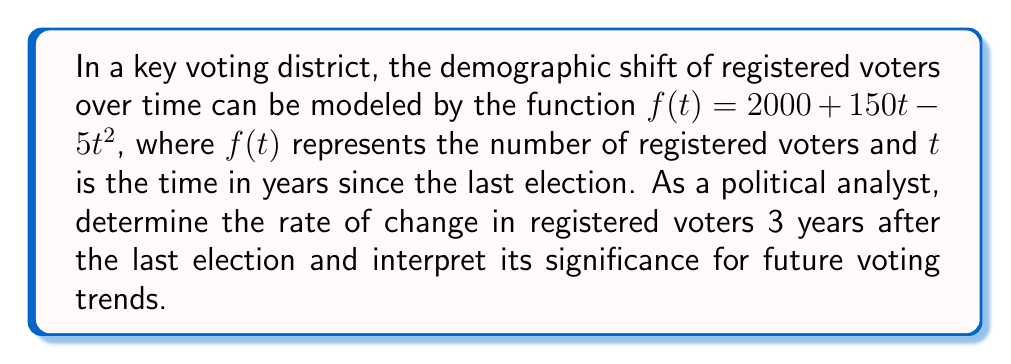What is the answer to this math problem? To solve this problem, we need to follow these steps:

1) The rate of change in registered voters is given by the derivative of the function $f(t)$.

2) Let's find the derivative of $f(t)$:
   $$f(t) = 2000 + 150t - 5t^2$$
   $$f'(t) = 150 - 10t$$

3) We need to find the rate of change 3 years after the last election, so we'll evaluate $f'(3)$:
   $$f'(3) = 150 - 10(3) = 150 - 30 = 120$$

4) Interpretation:
   The rate of change is positive, indicating that the number of registered voters is still increasing 3 years after the last election, but at a decreasing rate.
   
   The value 120 means that at t=3 years, the number of registered voters is increasing by 120 voters per year.

5) Future trend analysis:
   Since the second derivative $f''(t) = -10$ is negative, the rate of increase is slowing down. This suggests that the number of registered voters will eventually reach a peak and then start to decrease if this trend continues.

This information is crucial for political analysis as it indicates a potential shift in the voting demographics of the district, which could impact future election outcomes.
Answer: 120 voters/year, indicating a slowing growth in registered voters 